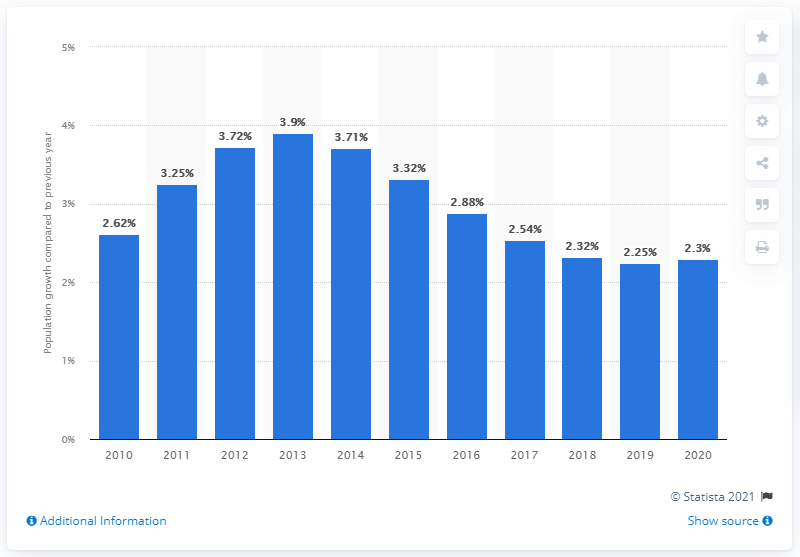Point out several critical features in this image. The population of Iraq in 2020 increased by 2.3 million. 